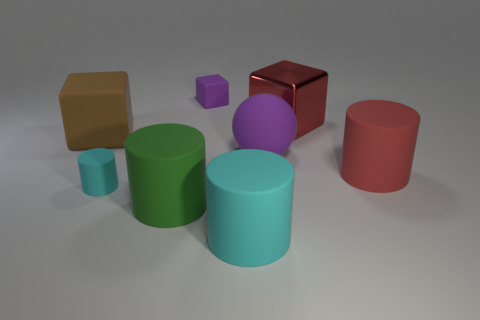Add 2 green matte objects. How many objects exist? 10 Subtract all matte blocks. How many blocks are left? 1 Subtract all brown cubes. How many cyan cylinders are left? 2 Subtract all red cylinders. How many cylinders are left? 3 Subtract all cubes. How many objects are left? 5 Subtract all yellow cylinders. Subtract all yellow balls. How many cylinders are left? 4 Add 4 cylinders. How many cylinders exist? 8 Subtract 0 blue blocks. How many objects are left? 8 Subtract all large gray objects. Subtract all green objects. How many objects are left? 7 Add 6 metal things. How many metal things are left? 7 